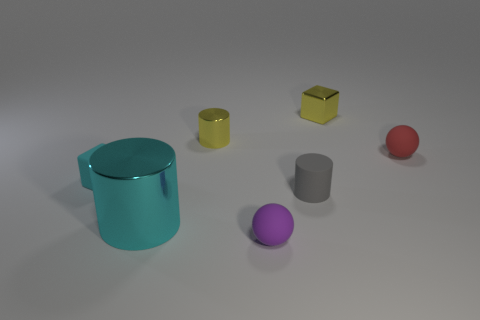Add 2 large cyan shiny cubes. How many objects exist? 9 Subtract all cylinders. How many objects are left? 4 Add 5 small cyan objects. How many small cyan objects exist? 6 Subtract 0 green blocks. How many objects are left? 7 Subtract all purple matte things. Subtract all small red shiny cylinders. How many objects are left? 6 Add 1 big cyan shiny cylinders. How many big cyan shiny cylinders are left? 2 